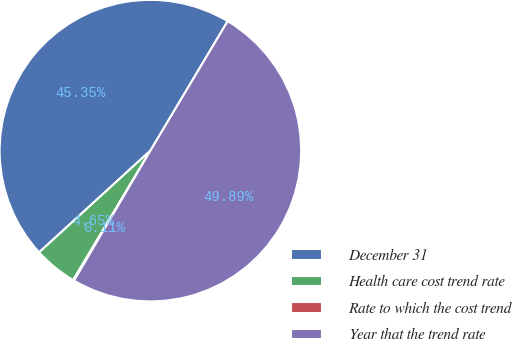<chart> <loc_0><loc_0><loc_500><loc_500><pie_chart><fcel>December 31<fcel>Health care cost trend rate<fcel>Rate to which the cost trend<fcel>Year that the trend rate<nl><fcel>45.35%<fcel>4.65%<fcel>0.11%<fcel>49.89%<nl></chart> 